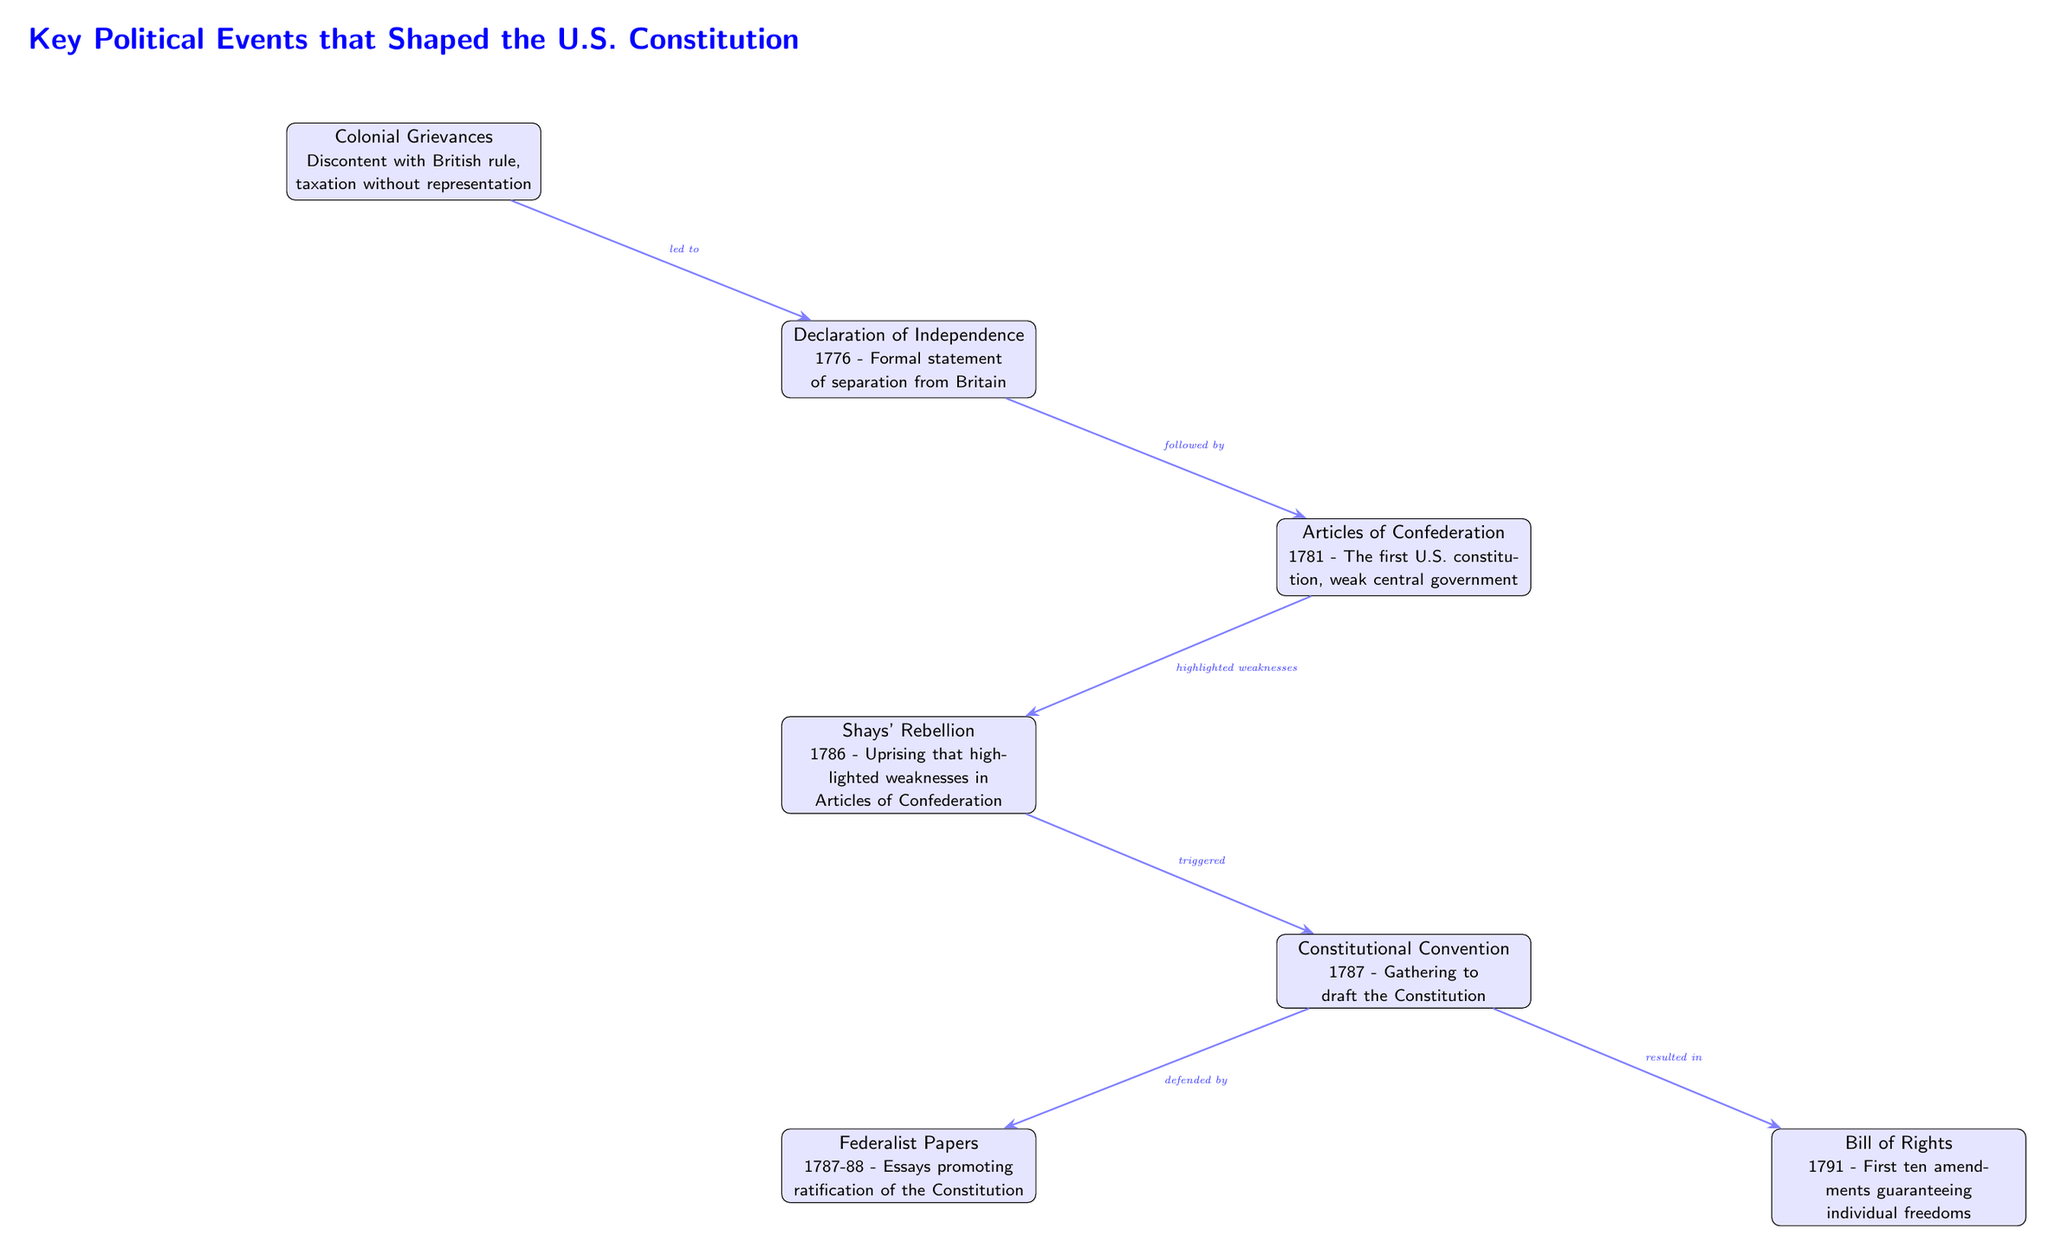What key event led to the Declaration of Independence? The diagram indicates that the Colonial Grievances event is the precursor to the Declaration of Independence. It shows an arrow from the Colonial Grievances to the Declaration of Independence, labeled "led to."
Answer: Colonial Grievances What year was the Articles of Confederation established? The diagram lists the Articles of Confederation and includes a footnote that denotes it was established in the year 1781.
Answer: 1781 How many events are directly connected to the Constitutional Convention? The diagram shows three events that have arrows pointing to the Constitutional Convention: Shays' Rebellion, Federalist Papers, and Bill of Rights. Therefore, there are three events directly connected to it.
Answer: 3 What document followed the Articles of Confederation? According to the flow in the diagram, the event that comes after the Articles of Confederation is the Constitutional Convention. This is indicated by an arrow labeled "followed by."
Answer: Constitutional Convention Which uprising highlighted the weaknesses in the Articles of Confederation? The diagram specifies that Shays' Rebellion is the uprising showing the weaknesses of the Articles of Confederation by illustrating a direct connection with an arrow labeled "highlighted weaknesses."
Answer: Shays' Rebellion What was the main purpose of the Federalist Papers? The diagram mentions that the Federalist Papers were created to promote ratification of the Constitution, as indicated by the label on the arrow connecting it to the Constitutional Convention.
Answer: Ratification What resulted from the Constitutional Convention? The diagram states that the outcome of the Constitutional Convention was the Bill of Rights, as shown by the arrow labeled "resulted in."
Answer: Bill of Rights What is the relationship between Shays' Rebellion and the Constitutional Convention? The diagram indicates that Shays' Rebellion triggered the Constitutional Convention, with an arrow labeled "triggered" pointing from Shays' Rebellion to the Convention.
Answer: Triggered What were the first ten amendments to the Constitution called? The diagram clearly states that the first ten amendments are referred to as the Bill of Rights, documented in the last portion of the diagram.
Answer: Bill of Rights 